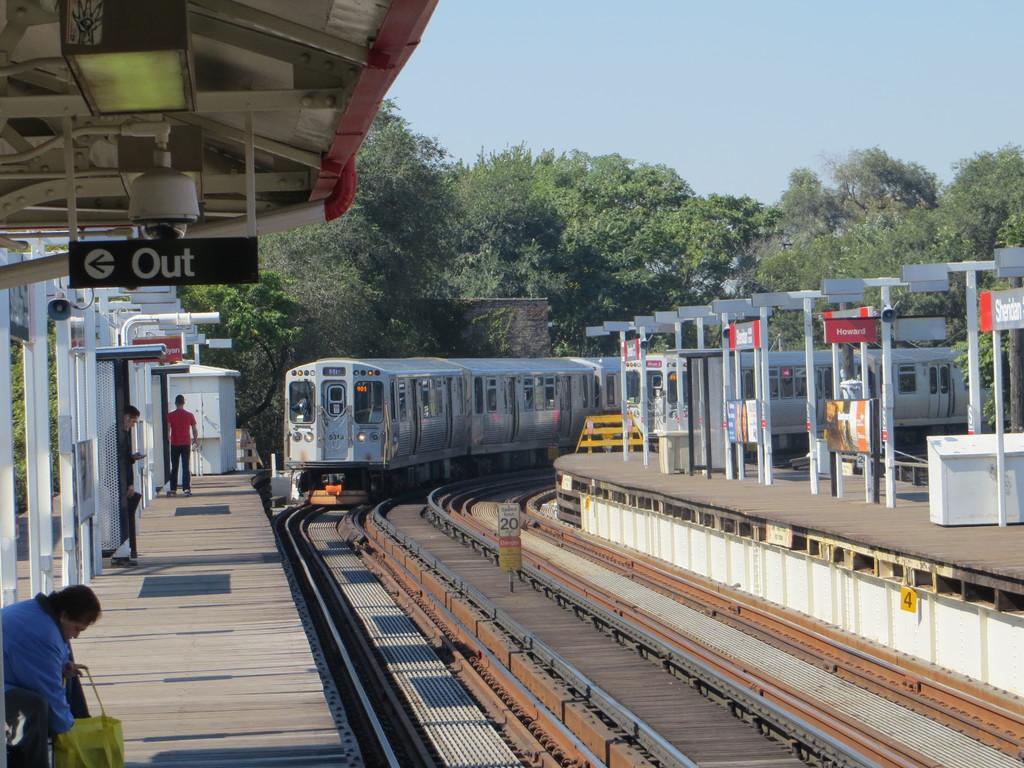How would you summarize this image in a sentence or two? This image is taken outdoors. At the top of the image there is a sky. In the background there are many trees. On the left and right sides of the image there are platforms with benches, a few boards with text on them and iron bars. A woman is standing on the platform. In the middle of the image a train is moving on the tracks. 